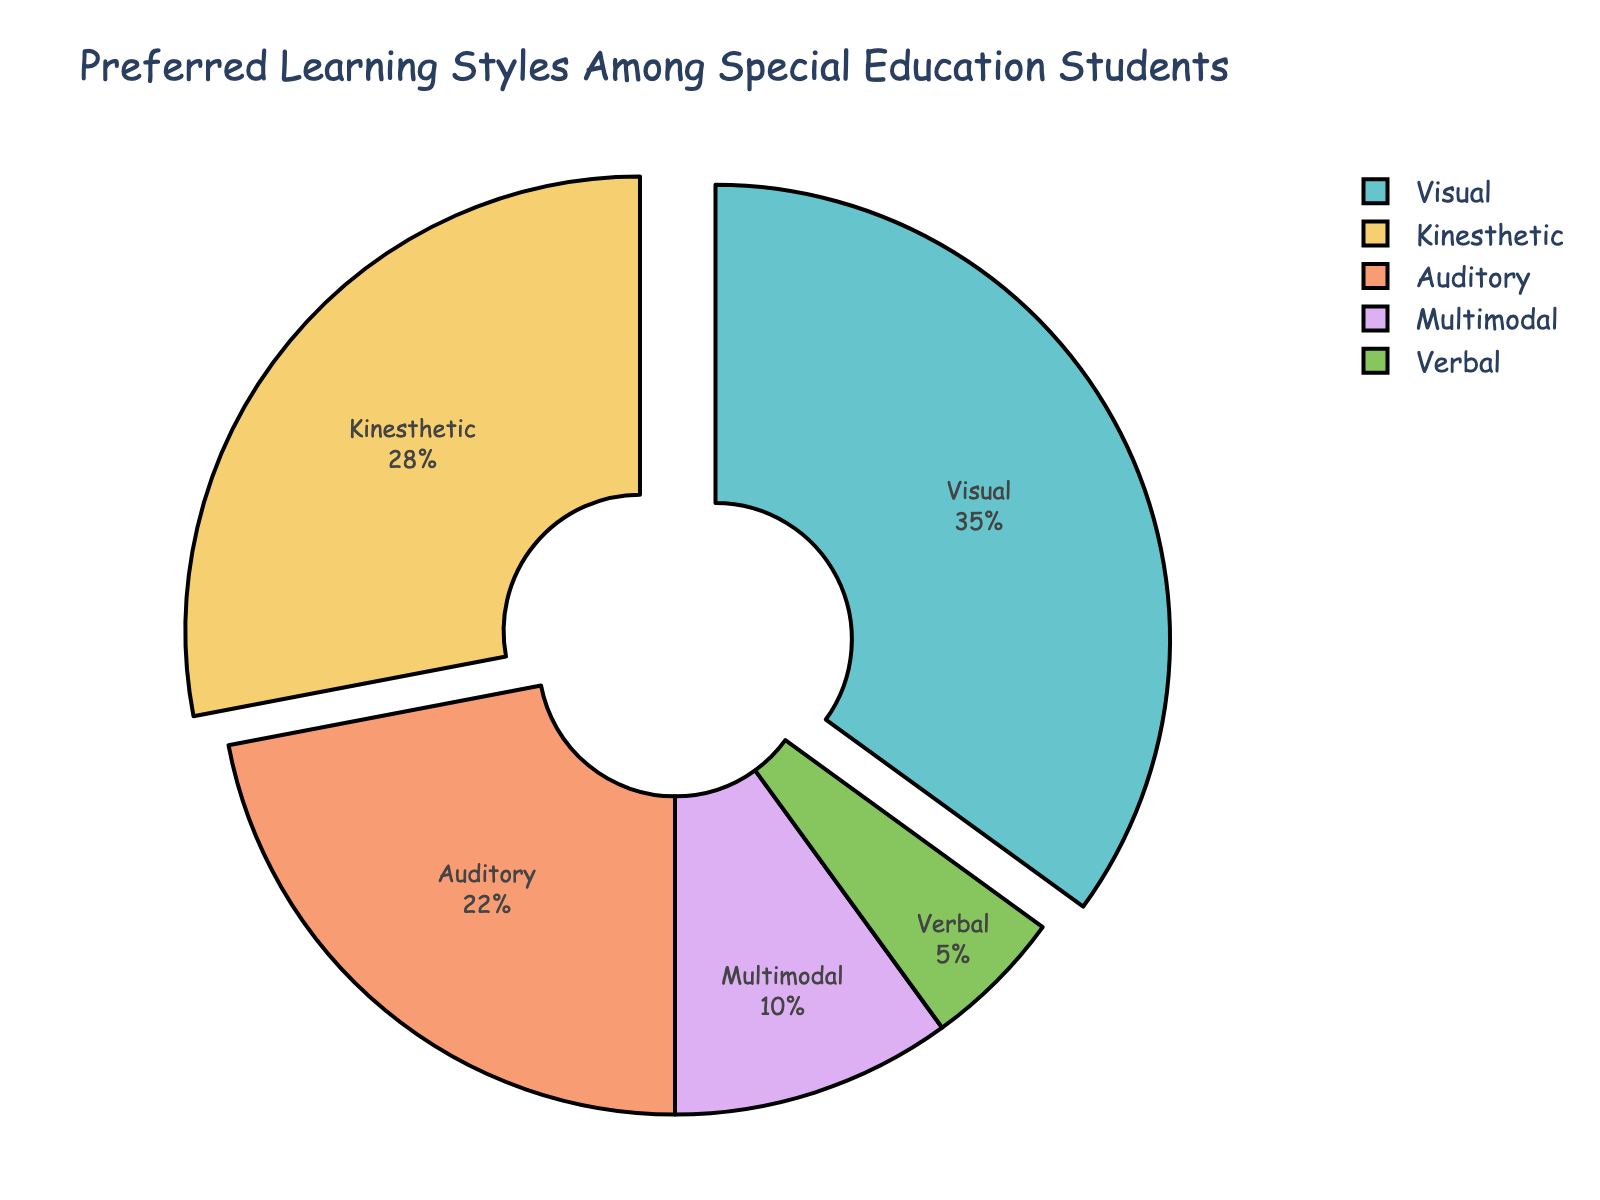What is the most preferred learning style among special education students? According to the pie chart, Visual learning style occupies the largest portion with 35% of the total.
Answer: Visual Which two learning styles make up over half of the student's preferences combined? Summing the percentages of Visual (35%) and Kinesthetic (28%) learning styles gives 63%, which is more than half of the total.
Answer: Visual and Kinesthetic Comparing Auditory and Verbal learning styles, which one is preferred by more students, and by how much? Auditory learning style is preferred by 22% of students, while Verbal is preferred by 5%. The difference between them is 22% - 5% = 17%.
Answer: Auditory by 17% What percentage of students prefers either Multimodal or Kinesthetic learning styles? Adding the percentages for Multimodal (10%) and Kinesthetic (28%) learning styles gives 10% + 28% = 38%.
Answer: 38% Which learning style is the least preferred among special education students? The smallest segment of the pie chart represents Verbal learning style with 5%.
Answer: Verbal Is the percentage of students who prefer Auditory learning style greater than those who prefer Multimodal and Verbal learning styles combined? Combined percentage of Multimodal (10%) and Verbal (5%) is 15%. Auditory learning style is preferred by 22% of students, which is greater than 15%.
Answer: Yes If we combine Visual and Auditory preferences, what portion of the total do they represent? Adding the percentages for Visual (35%) and Auditory (22%) learning styles gives 35% + 22% = 57%.
Answer: 57% How does the percentage of Kinesthetic learners compare to that of Auditory learners? Kinesthetic learning style accounts for 28% and Auditory accounts for 22%. Kinesthetic is preferred by 6% more students than Auditory.
Answer: Kinesthetic is 6% more Which learning style would need additional focus if we want to support an equal number of students across all learning styles? Verbal has the smallest percentage (5%) of preference among students, indicating it might need additional focus to balance support among all styles.
Answer: Verbal What is the combined preference percentage for the learning styles that fall below 30%? Summing the percentages for Auditory (22%), Kinesthetic (28%), Multimodal (10%), and Verbal (5%) gives us 22% + 28% + 10% + 5% = 65%.
Answer: 65% 